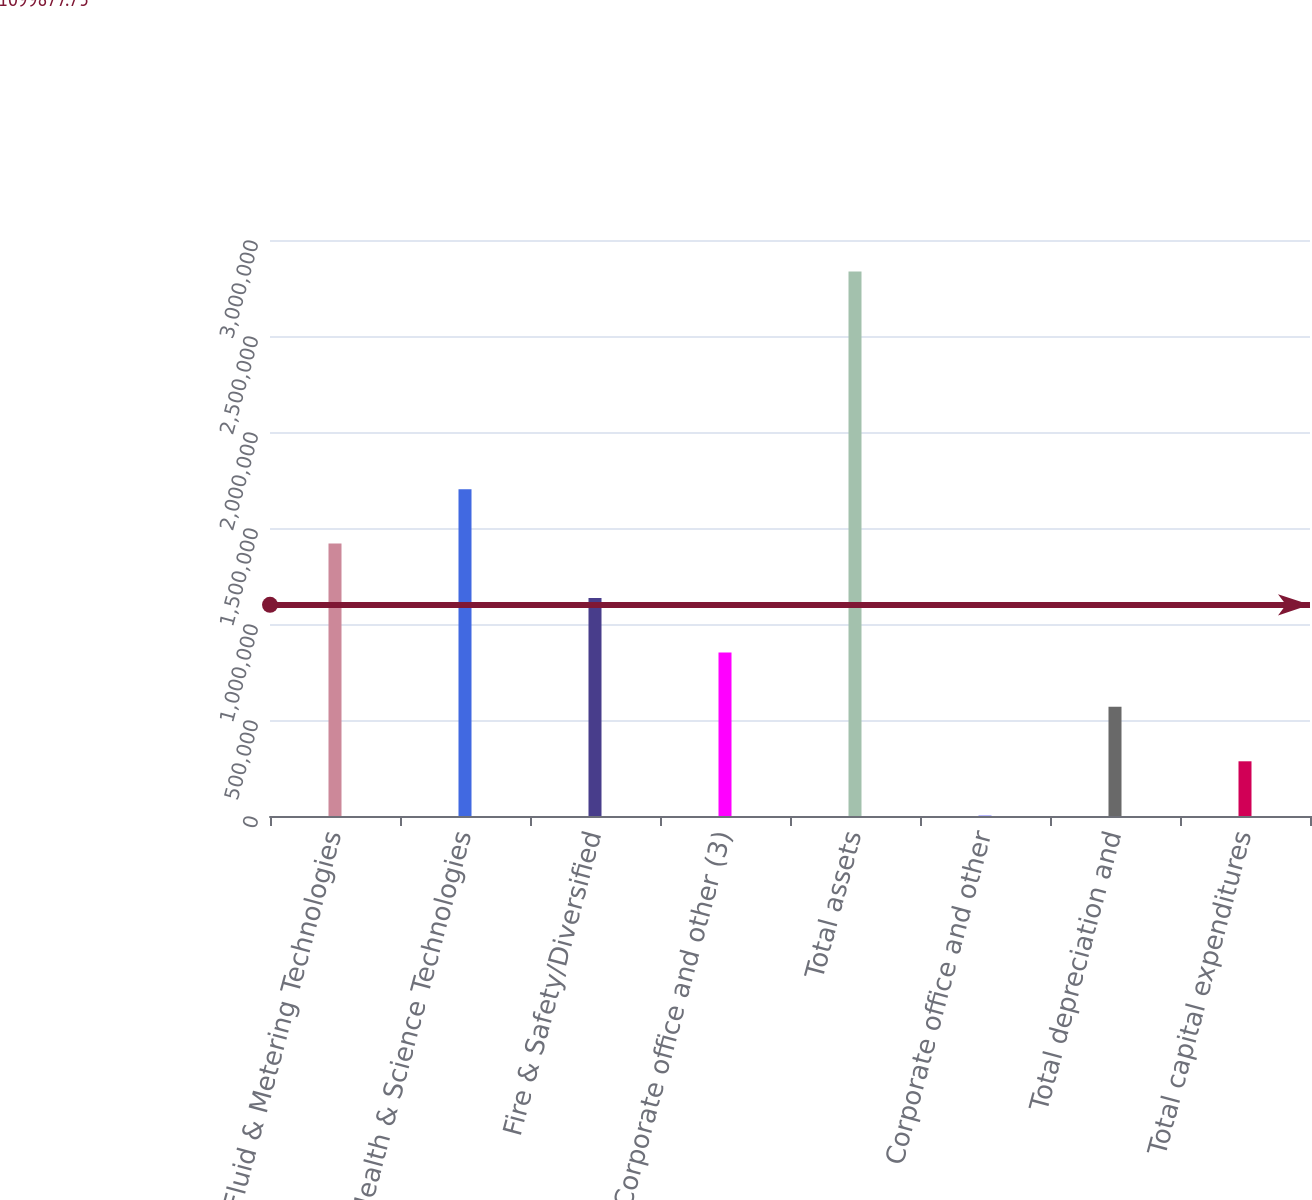<chart> <loc_0><loc_0><loc_500><loc_500><bar_chart><fcel>Fluid & Metering Technologies<fcel>Health & Science Technologies<fcel>Fire & Safety/Diversified<fcel>Corporate office and other (3)<fcel>Total assets<fcel>Corporate office and other<fcel>Total depreciation and<fcel>Total capital expenditures<nl><fcel>1.41878e+06<fcel>1.70224e+06<fcel>1.13531e+06<fcel>851845<fcel>2.83611e+06<fcel>1447<fcel>568379<fcel>284913<nl></chart> 